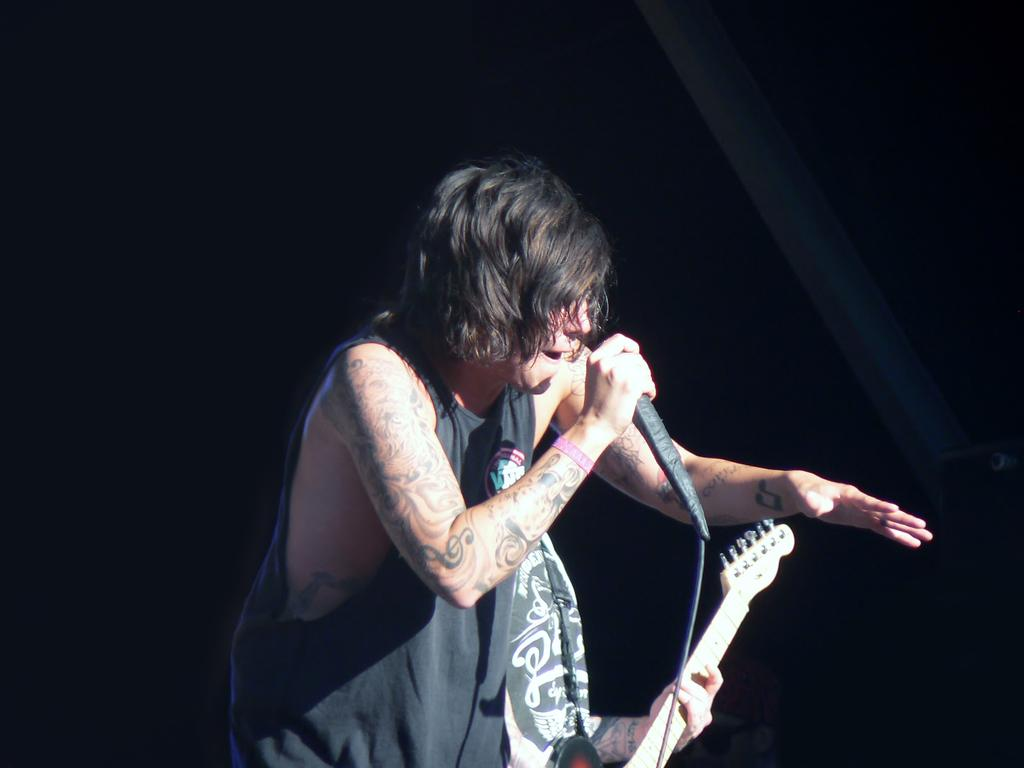What is the person on the left side of the image holding? The person on the left is holding a microphone with a cable in his hand. What is the person on the right side of the image holding? The person on the right is holding a guitar in his hand. How much salt is visible on the desk in the image? There is no desk or salt present in the image. What other things can be seen in the image besides the microphone and guitar? The provided facts do not mention any other items in the image besides the microphone and guitar. 